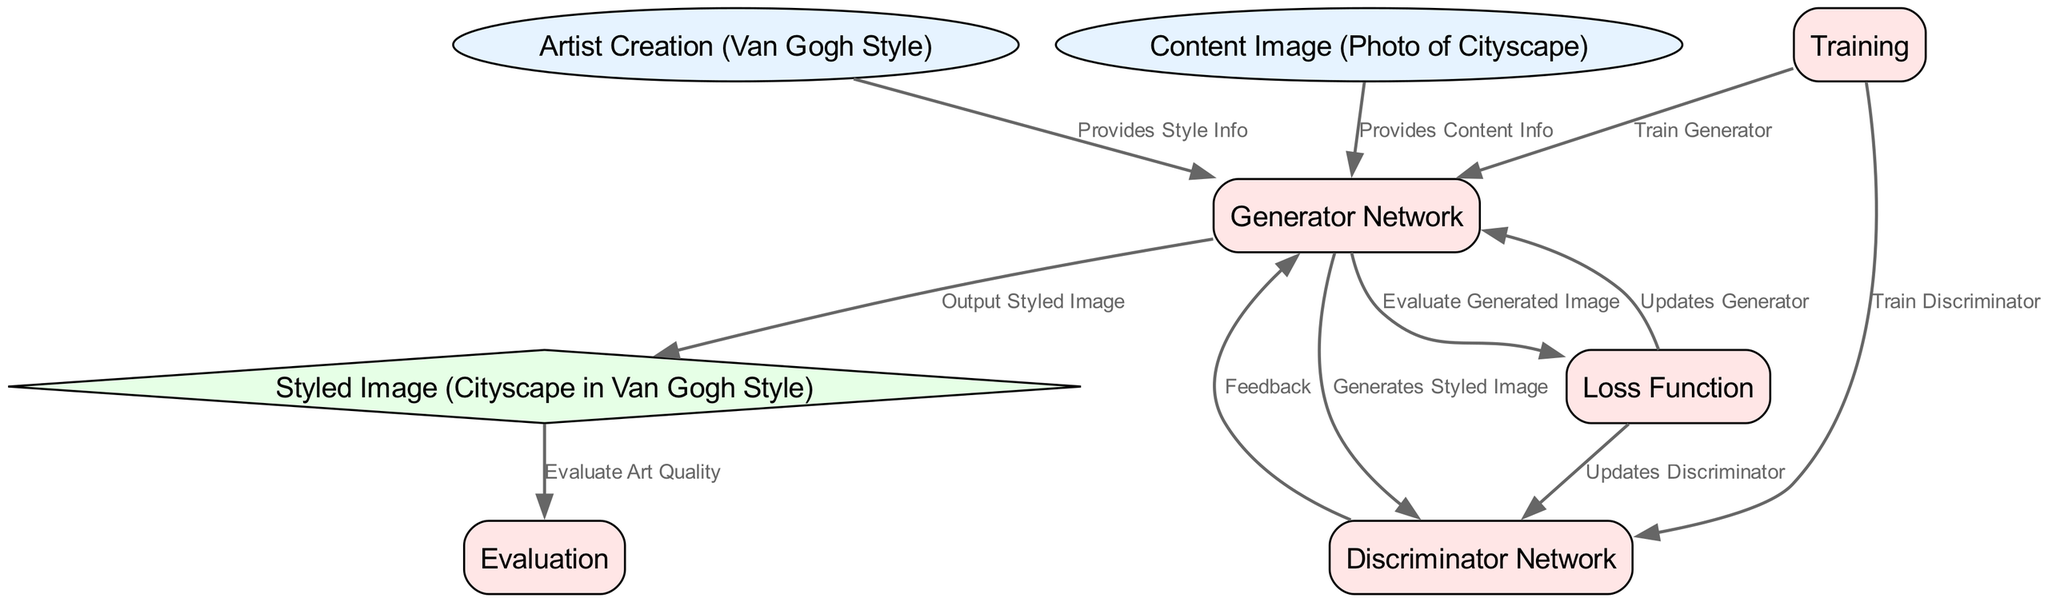What are the input nodes in the diagram? The input nodes listed in the diagram are "Artist Creation (Van Gogh Style)" and "Content Image (Photo of Cityscape)".
Answer: Artist Creation (Van Gogh Style), Content Image (Photo of Cityscape) Which node generates the styled image? The node responsible for generating the styled image is "Generator Network", as it outputs "Styled Image (Cityscape in Van Gogh Style)".
Answer: Generator Network What type of node is 'Styled Image (Cityscape in Van Gogh Style)'? The 'Styled Image (Cityscape in Van Gogh Style)' is categorized as an output node, as it is displayed in a diamond shape.
Answer: output How many processes are involved in the diagram? The diagram contains five process nodes: "Generator Network", "Discriminator Network", "Loss Function", "Training", and "Evaluation".
Answer: five Which node provides content information to the generator network? The "Content Image (Photo of Cityscape)" node provides the content information necessary for the generator network to operate.
Answer: Content Image (Photo of Cityscape) What is the feedback mechanism between the discriminator network and the generator network? The "Discriminator Network" sends feedback back to the "Generator Network" to refine its generation of the styled image.
Answer: Feedback What updates occur based on the loss function's evaluation? The loss function updates both the "Discriminator Network" and the "Generator Network" based on the evaluation of the generated images.
Answer: Updates Discriminator, Updates Generator What is the output of the generator network? The output generated by the generator network is the "Styled Image (Cityscape in Van Gogh Style)", which is the final styled artwork.
Answer: Styled Image (Cityscape in Van Gogh Style) What evaluation is performed on the styled image? The evaluation that is conducted on the styled image is to assess its quality as art through the "Evaluation" process node.
Answer: Evaluate Art Quality 